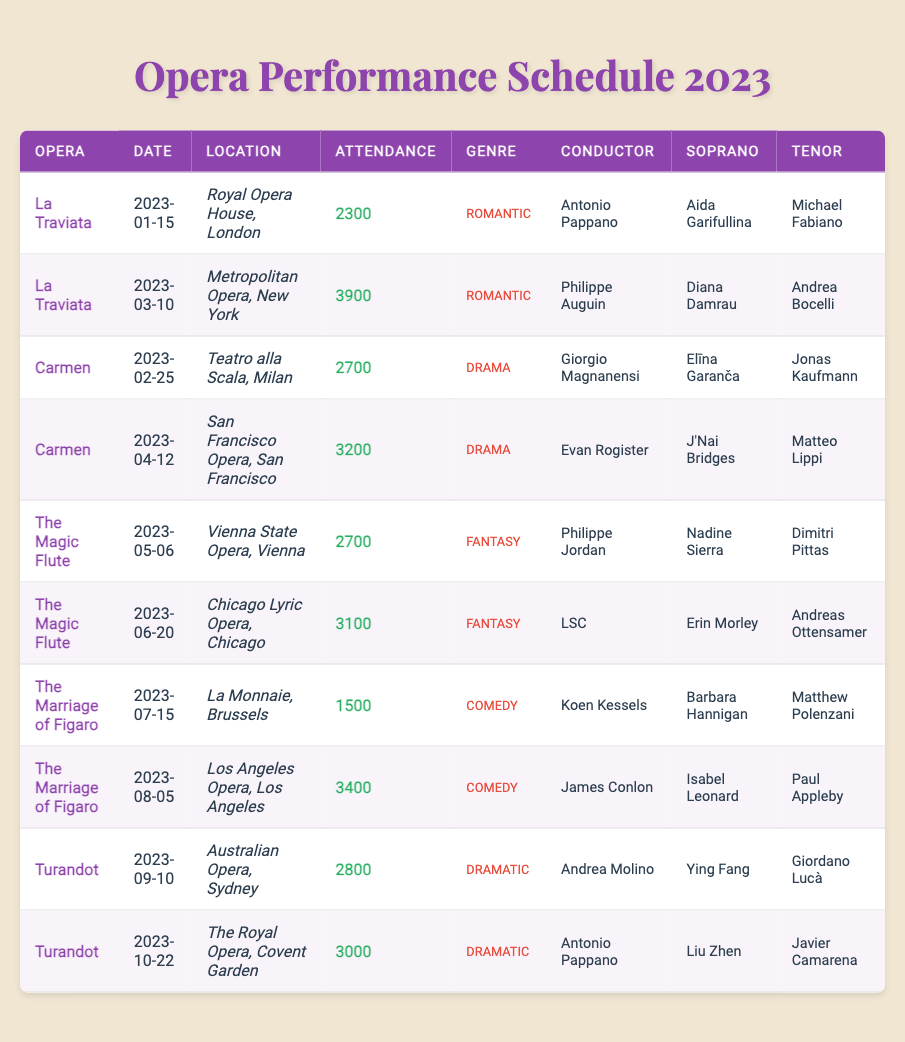What is the highest attendance number among the performances? The attendance numbers are 2300, 3900, 2700, 3200, 2700, 3100, 1500, 3400, 2800, and 3000. The highest number is 3900, which corresponds to the performance of La Traviata on March 10 at the Metropolitan Opera, New York.
Answer: 3900 How many performances of Carmen took place in 2023? There are two performances of Carmen listed: one on February 25 at Teatro alla Scala, Milan, and another on April 12 at San Francisco Opera, San Francisco.
Answer: 2 What genre is La Traviata categorized under? The genre listed for La Traviata is "Romantic."
Answer: Romantic What was the total attendance for The Magic Flute performances in 2023? The attendance for The Magic Flute is 2700 (May 6) and 3100 (June 20). Adding these together gives 2700 + 3100 = 5800.
Answer: 5800 Which opera had the lowest attendance, and what was that number? The attendance numbers show that the lowest is 1500, which corresponds to The Marriage of Figaro performance on July 15 in Brussels.
Answer: The Marriage of Figaro, 1500 Who conducted the performance of Turandot at The Royal Opera, Covent Garden? The performance on October 22, 2023, of Turandot at The Royal Opera, Covent Garden, was conducted by Antonio Pappano.
Answer: Antonio Pappano What is the average attendance across all performances of Carmen in 2023? The attendance for Carmen performances are 2700 and 3200. The sum is 2700 + 3200 = 5900, and dividing by 2 gives an average of 5900 / 2 = 2950.
Answer: 2950 How many performances occurred in the month of June 2023? There is one performance listed for June 2023, which is The Magic Flute on June 20 at Chicago Lyric Opera.
Answer: 1 Did any operas have performances at both the Royal Opera and the Metropolitan Opera? Yes, La Traviata was performed at both the Royal Opera House in London and at the Metropolitan Opera in New York.
Answer: Yes Which opera featured Elīna Garanča as the soprano? Elīna Garanča is listed as the soprano for the performance of Carmen on February 25 at Teatro alla Scala, Milan.
Answer: Carmen What was the total attendance for all performances of La Traviata? The attendance for La Traviata is 2300 (January 15) and 3900 (March 10). Adding these gives 2300 + 3900 = 6200.
Answer: 6200 Which location hosted the highest total attendance for a single performance? The highest attendance was for La Traviata at the Metropolitan Opera in New York, with 3900 attendees.
Answer: Metropolitan Opera, New York What is the genre of the opera performed at La Monnaie, Brussels, on July 15? The opera performed at La Monnaie, Brussels, on July 15 is The Marriage of Figaro, which is categorized under "Comedy."
Answer: Comedy How many different conductors worked on performances of The Magic Flute in 2023? Two conductors are listed: Philippe Jordan for the May 6 performance and LSC for the June 20 performance, giving a total of 2 different conductors.
Answer: 2 What is the total number of unique operas listed in the table? Five operas are listed: La Traviata, Carmen, The Magic Flute, The Marriage of Figaro, and Turandot.
Answer: 5 